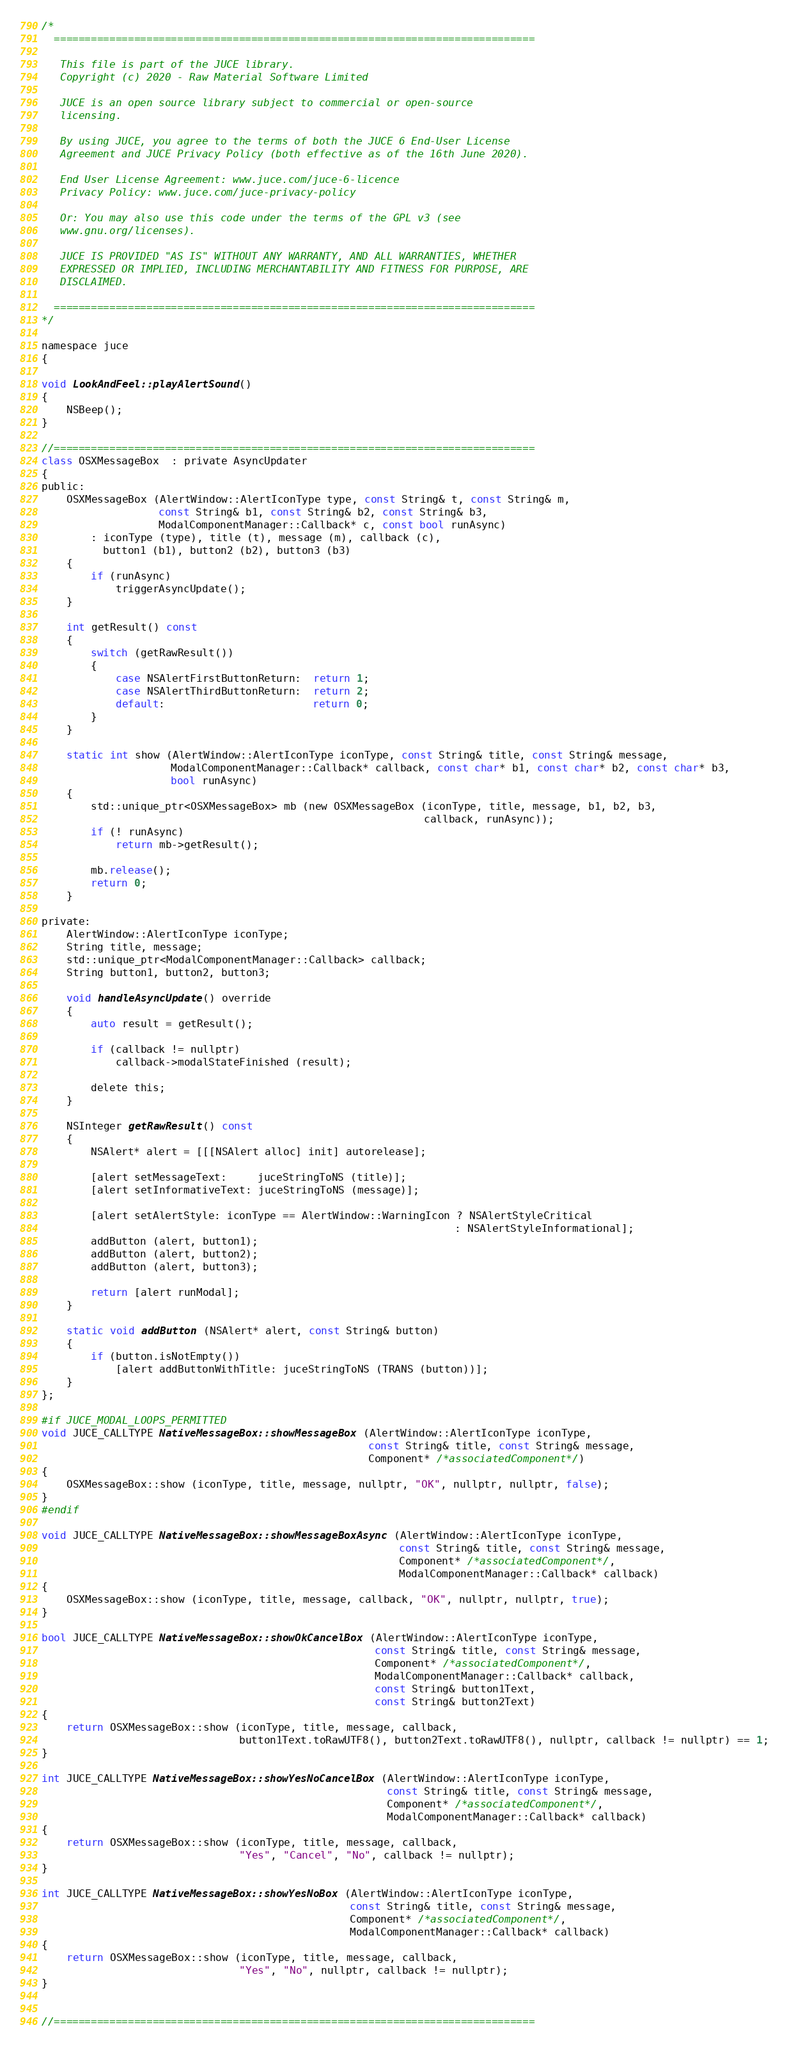Convert code to text. <code><loc_0><loc_0><loc_500><loc_500><_ObjectiveC_>/*
  ==============================================================================

   This file is part of the JUCE library.
   Copyright (c) 2020 - Raw Material Software Limited

   JUCE is an open source library subject to commercial or open-source
   licensing.

   By using JUCE, you agree to the terms of both the JUCE 6 End-User License
   Agreement and JUCE Privacy Policy (both effective as of the 16th June 2020).

   End User License Agreement: www.juce.com/juce-6-licence
   Privacy Policy: www.juce.com/juce-privacy-policy

   Or: You may also use this code under the terms of the GPL v3 (see
   www.gnu.org/licenses).

   JUCE IS PROVIDED "AS IS" WITHOUT ANY WARRANTY, AND ALL WARRANTIES, WHETHER
   EXPRESSED OR IMPLIED, INCLUDING MERCHANTABILITY AND FITNESS FOR PURPOSE, ARE
   DISCLAIMED.

  ==============================================================================
*/

namespace juce
{

void LookAndFeel::playAlertSound()
{
    NSBeep();
}

//==============================================================================
class OSXMessageBox  : private AsyncUpdater
{
public:
    OSXMessageBox (AlertWindow::AlertIconType type, const String& t, const String& m,
                   const String& b1, const String& b2, const String& b3,
                   ModalComponentManager::Callback* c, const bool runAsync)
        : iconType (type), title (t), message (m), callback (c),
          button1 (b1), button2 (b2), button3 (b3)
    {
        if (runAsync)
            triggerAsyncUpdate();
    }

    int getResult() const
    {
        switch (getRawResult())
        {
            case NSAlertFirstButtonReturn:  return 1;
            case NSAlertThirdButtonReturn:  return 2;
            default:                        return 0;
        }
    }

    static int show (AlertWindow::AlertIconType iconType, const String& title, const String& message,
                     ModalComponentManager::Callback* callback, const char* b1, const char* b2, const char* b3,
                     bool runAsync)
    {
        std::unique_ptr<OSXMessageBox> mb (new OSXMessageBox (iconType, title, message, b1, b2, b3,
                                                              callback, runAsync));
        if (! runAsync)
            return mb->getResult();

        mb.release();
        return 0;
    }

private:
    AlertWindow::AlertIconType iconType;
    String title, message;
    std::unique_ptr<ModalComponentManager::Callback> callback;
    String button1, button2, button3;

    void handleAsyncUpdate() override
    {
        auto result = getResult();

        if (callback != nullptr)
            callback->modalStateFinished (result);

        delete this;
    }

    NSInteger getRawResult() const
    {
        NSAlert* alert = [[[NSAlert alloc] init] autorelease];

        [alert setMessageText:     juceStringToNS (title)];
        [alert setInformativeText: juceStringToNS (message)];

        [alert setAlertStyle: iconType == AlertWindow::WarningIcon ? NSAlertStyleCritical
                                                                   : NSAlertStyleInformational];
        addButton (alert, button1);
        addButton (alert, button2);
        addButton (alert, button3);

        return [alert runModal];
    }

    static void addButton (NSAlert* alert, const String& button)
    {
        if (button.isNotEmpty())
            [alert addButtonWithTitle: juceStringToNS (TRANS (button))];
    }
};

#if JUCE_MODAL_LOOPS_PERMITTED
void JUCE_CALLTYPE NativeMessageBox::showMessageBox (AlertWindow::AlertIconType iconType,
                                                     const String& title, const String& message,
                                                     Component* /*associatedComponent*/)
{
    OSXMessageBox::show (iconType, title, message, nullptr, "OK", nullptr, nullptr, false);
}
#endif

void JUCE_CALLTYPE NativeMessageBox::showMessageBoxAsync (AlertWindow::AlertIconType iconType,
                                                          const String& title, const String& message,
                                                          Component* /*associatedComponent*/,
                                                          ModalComponentManager::Callback* callback)
{
    OSXMessageBox::show (iconType, title, message, callback, "OK", nullptr, nullptr, true);
}

bool JUCE_CALLTYPE NativeMessageBox::showOkCancelBox (AlertWindow::AlertIconType iconType,
                                                      const String& title, const String& message,
                                                      Component* /*associatedComponent*/,
                                                      ModalComponentManager::Callback* callback,
                                                      const String& button1Text,
                                                      const String& button2Text)
{
    return OSXMessageBox::show (iconType, title, message, callback,
                                button1Text.toRawUTF8(), button2Text.toRawUTF8(), nullptr, callback != nullptr) == 1;
}

int JUCE_CALLTYPE NativeMessageBox::showYesNoCancelBox (AlertWindow::AlertIconType iconType,
                                                        const String& title, const String& message,
                                                        Component* /*associatedComponent*/,
                                                        ModalComponentManager::Callback* callback)
{
    return OSXMessageBox::show (iconType, title, message, callback,
                                "Yes", "Cancel", "No", callback != nullptr);
}

int JUCE_CALLTYPE NativeMessageBox::showYesNoBox (AlertWindow::AlertIconType iconType,
                                                  const String& title, const String& message,
                                                  Component* /*associatedComponent*/,
                                                  ModalComponentManager::Callback* callback)
{
    return OSXMessageBox::show (iconType, title, message, callback,
                                "Yes", "No", nullptr, callback != nullptr);
}


//==============================================================================</code> 